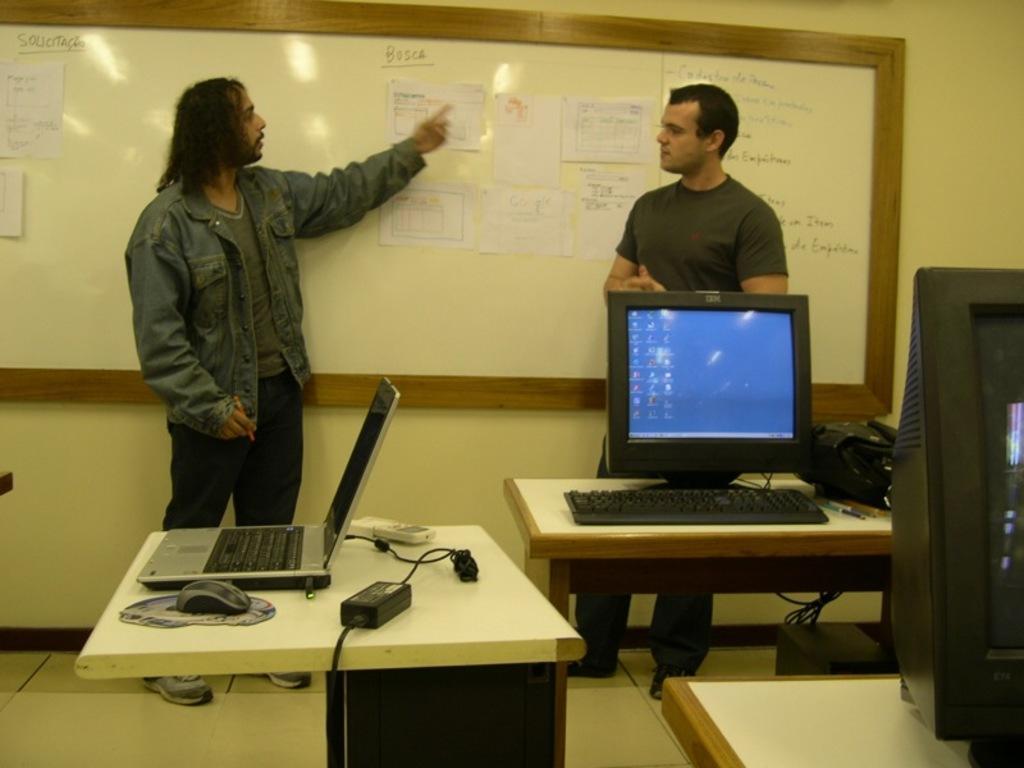How would you summarize this image in a sentence or two? In this image I can see two men are standing. Here I can see number of tables and also a laptop, a monitor and a keyboard. 